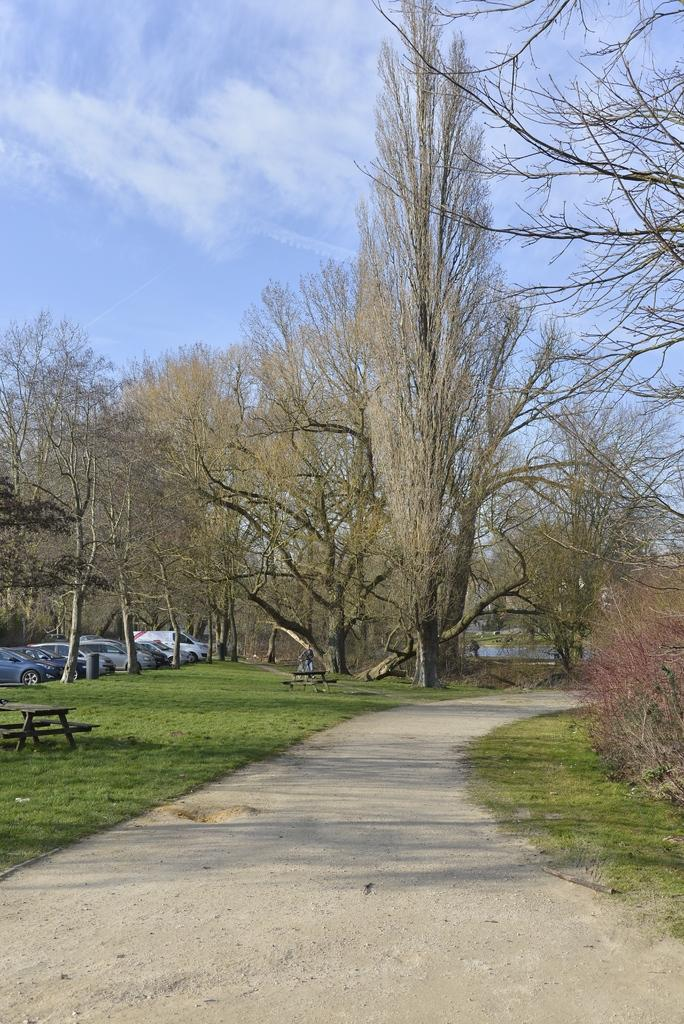What type of natural elements can be seen in the image? There are trees in the image. What man-made objects are present in the image? There are vehicles and benches in the image. Is there any indication of human presence in the image? Yes, there is a person in the image. What is visible in the sky in the image? There are clouds in the sky. What surface can be seen at the bottom of the image? There is a road at the bottom of the image. Can you see any corn growing in the image? There is no corn visible in the image. What type of sand can be seen on the beach in the image? There is no beach or sand present in the image. 